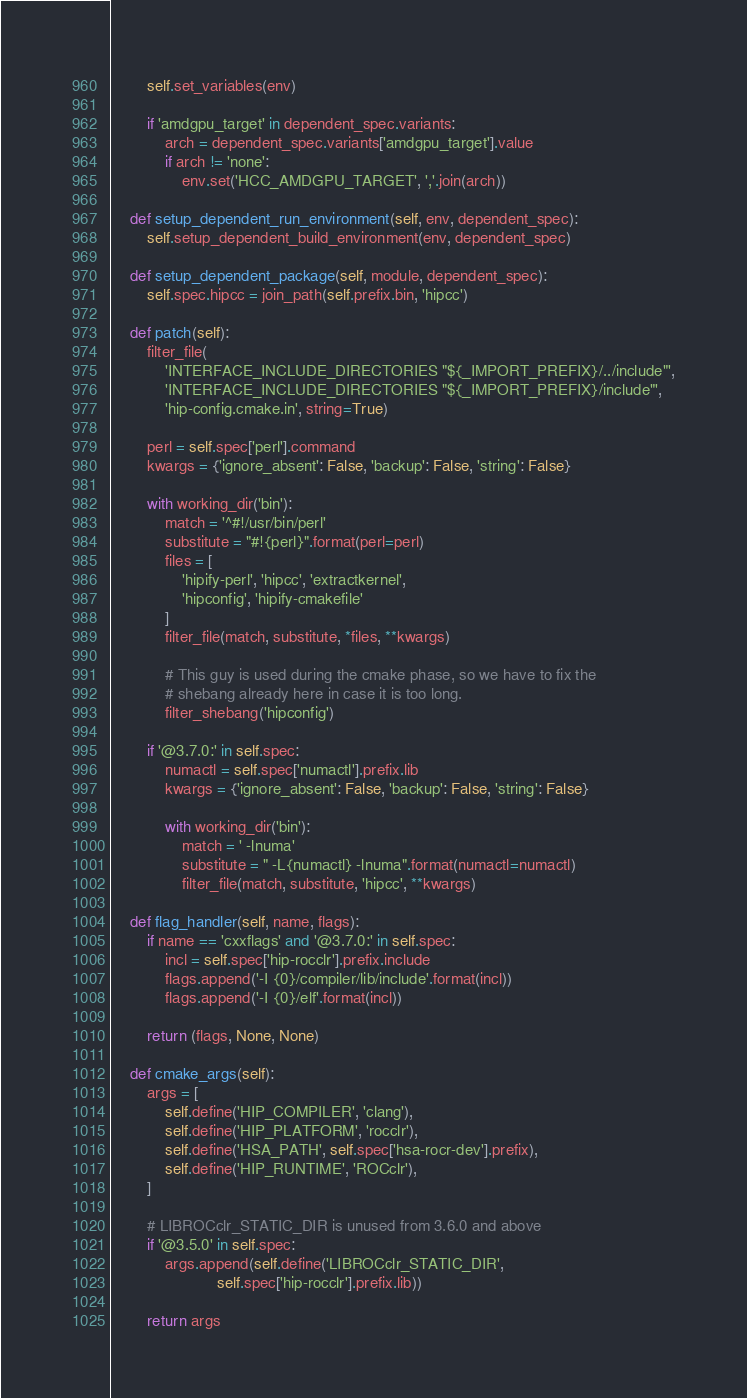<code> <loc_0><loc_0><loc_500><loc_500><_Python_>        self.set_variables(env)

        if 'amdgpu_target' in dependent_spec.variants:
            arch = dependent_spec.variants['amdgpu_target'].value
            if arch != 'none':
                env.set('HCC_AMDGPU_TARGET', ','.join(arch))

    def setup_dependent_run_environment(self, env, dependent_spec):
        self.setup_dependent_build_environment(env, dependent_spec)

    def setup_dependent_package(self, module, dependent_spec):
        self.spec.hipcc = join_path(self.prefix.bin, 'hipcc')

    def patch(self):
        filter_file(
            'INTERFACE_INCLUDE_DIRECTORIES "${_IMPORT_PREFIX}/../include"',
            'INTERFACE_INCLUDE_DIRECTORIES "${_IMPORT_PREFIX}/include"',
            'hip-config.cmake.in', string=True)

        perl = self.spec['perl'].command
        kwargs = {'ignore_absent': False, 'backup': False, 'string': False}

        with working_dir('bin'):
            match = '^#!/usr/bin/perl'
            substitute = "#!{perl}".format(perl=perl)
            files = [
                'hipify-perl', 'hipcc', 'extractkernel',
                'hipconfig', 'hipify-cmakefile'
            ]
            filter_file(match, substitute, *files, **kwargs)

            # This guy is used during the cmake phase, so we have to fix the
            # shebang already here in case it is too long.
            filter_shebang('hipconfig')

        if '@3.7.0:' in self.spec:
            numactl = self.spec['numactl'].prefix.lib
            kwargs = {'ignore_absent': False, 'backup': False, 'string': False}

            with working_dir('bin'):
                match = ' -lnuma'
                substitute = " -L{numactl} -lnuma".format(numactl=numactl)
                filter_file(match, substitute, 'hipcc', **kwargs)

    def flag_handler(self, name, flags):
        if name == 'cxxflags' and '@3.7.0:' in self.spec:
            incl = self.spec['hip-rocclr'].prefix.include
            flags.append('-I {0}/compiler/lib/include'.format(incl))
            flags.append('-I {0}/elf'.format(incl))

        return (flags, None, None)

    def cmake_args(self):
        args = [
            self.define('HIP_COMPILER', 'clang'),
            self.define('HIP_PLATFORM', 'rocclr'),
            self.define('HSA_PATH', self.spec['hsa-rocr-dev'].prefix),
            self.define('HIP_RUNTIME', 'ROCclr'),
        ]

        # LIBROCclr_STATIC_DIR is unused from 3.6.0 and above
        if '@3.5.0' in self.spec:
            args.append(self.define('LIBROCclr_STATIC_DIR',
                        self.spec['hip-rocclr'].prefix.lib))

        return args
</code> 